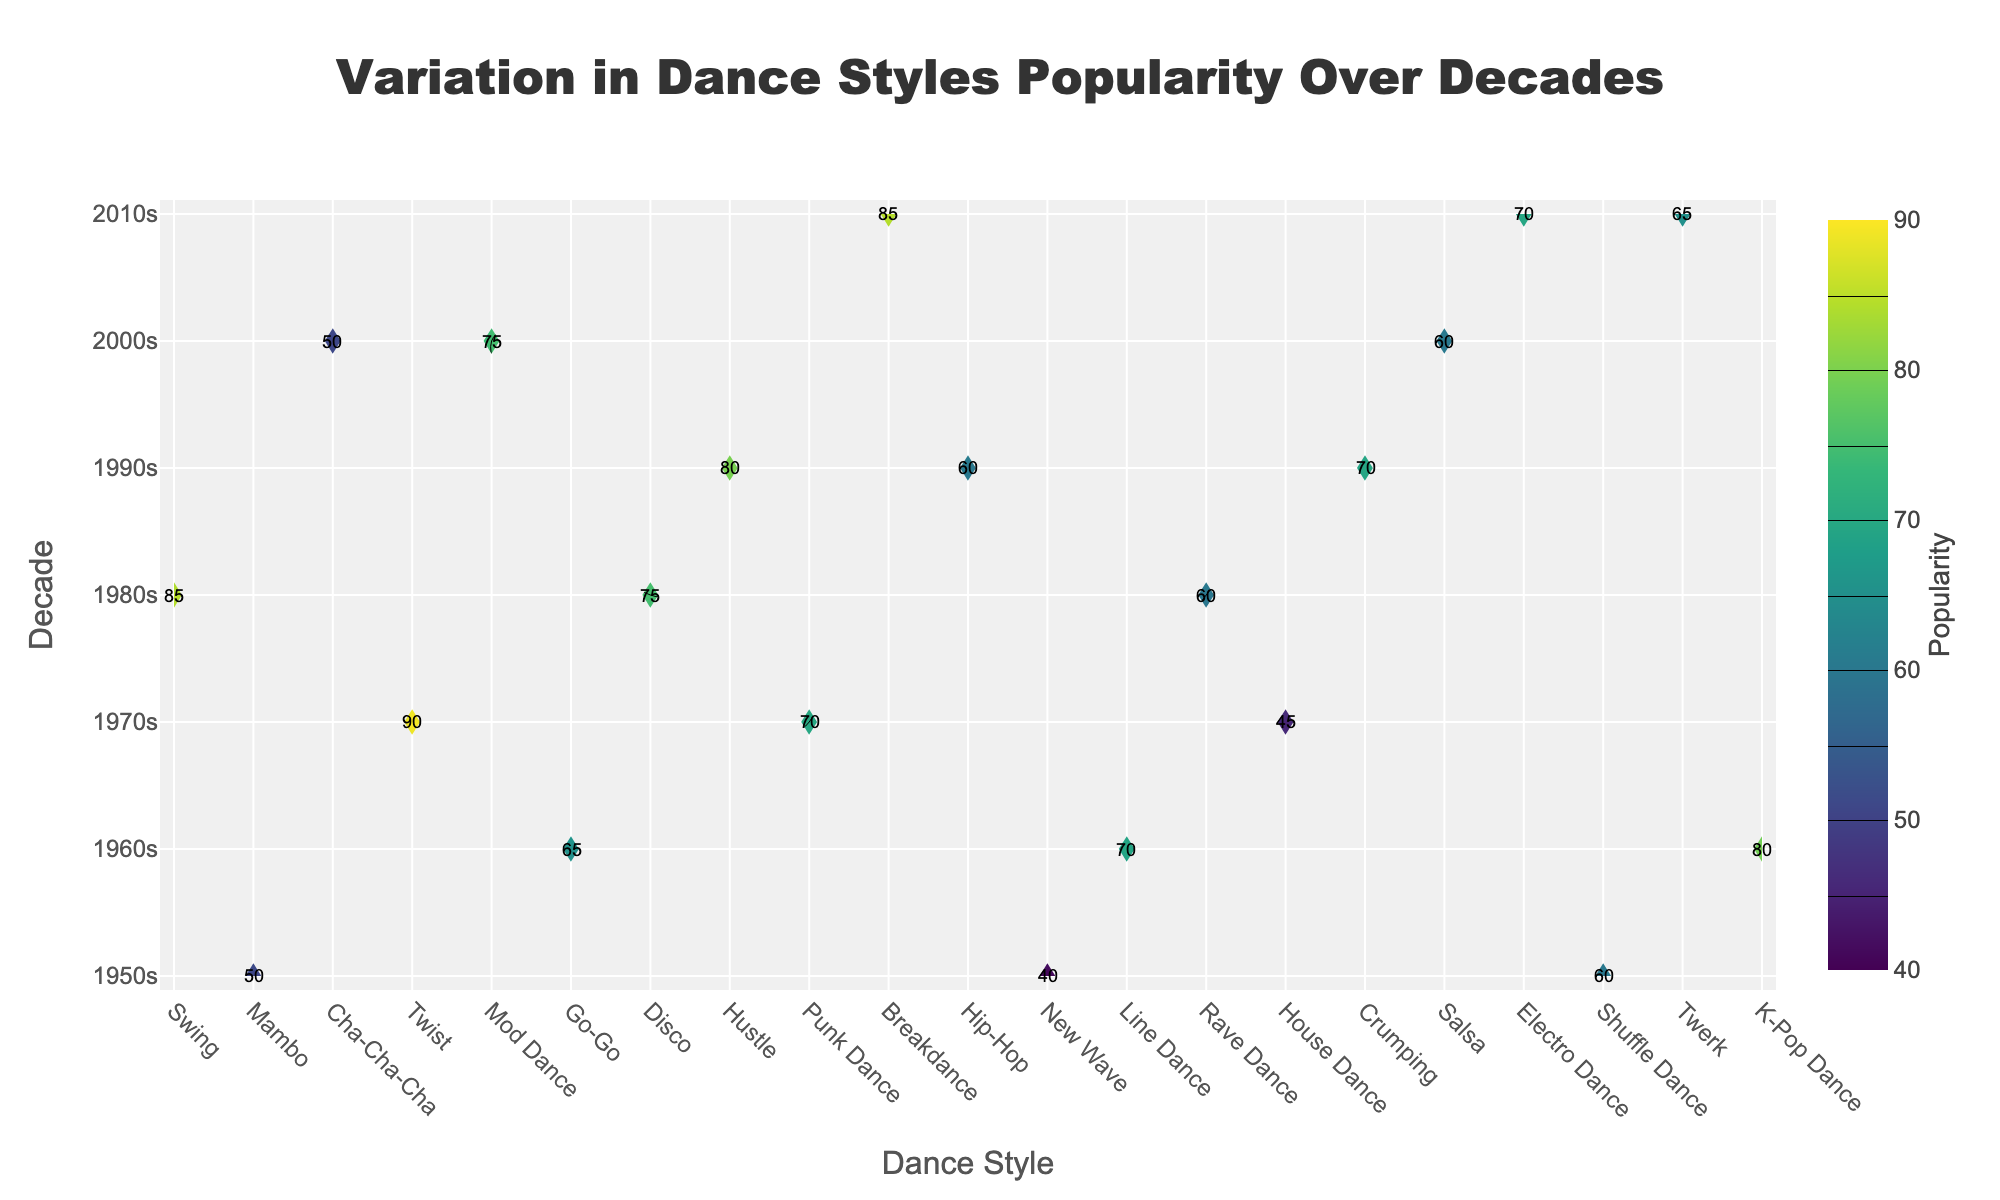what is the most popular dance style in the 1960s? Look for the highest number under the 1960s on the y-axis and find the corresponding dance style on the x-axis. The highest value in the 1960s is 80, which corresponds to the dance style "Twist".
Answer: Twist which decade saw the highest popularity for disco? First, find the dance style "Disco" on the x-axis. Next, follow the column up to see which decade has the highest popularity. Disco's value is highest in the 1970s with a value of 90.
Answer: 1970s how did the popularity of breakdance in the 1980s compare to the popularity of hip-hop in the same decade? Look at the popularity values for both Breakdance and Hip-Hop in the 1980s. Breakdance has a value of 85, and Hip-Hop has a value of 75. Breakdance is more popular than Hip-Hop by a difference of 10.
Answer: Breakdance is more popular what is the average popularity of dance styles in the 2000s? Sum the popularity of Crumping (50), Salsa (60), and Electro Dance (75), and then divide by the number of dance styles (3). The average is (50 + 60 + 75)/3 = 185/3 = 61.67
Answer: 61.67 which dance style had the lowest popularity in the 1970s? Find the lowest number under the 1970s section on the y-axis. The lowest value is 45, which corresponds to Punk Dance.
Answer: Punk Dance how does the popularity of K-Pop dance in the 2010s compare to the popularity of Twist in the 1960s? Check the popularity values of K-Pop Dance in the 2010s and Twist in the 1960s. K-Pop Dance has a value of 85, while Twist has a value of 80. Therefore, K-Pop Dance is more popular by a margin of 5.
Answer: K-Pop Dance is more popular what is the total popularity of all dance styles in the 1950s? Sum the popularity of Swing (60), Mambo (40), and Cha-Cha-Cha (50) in the 1950s. The total is 60 + 40 + 50 = 150.
Answer: 150 which decade has the most uniformly popular dance styles in terms of spread? Evaluate the range of popularity for each decade by subtracting the lowest value from the highest value within each decade. The lower the range, the more uniform the popularity. For example, the 1970s have values ranging from 45 to 90, giving a spread of 45. Do the same for other decades, and the one with the smallest spread is the most uniform.
Answer: To be calculated 